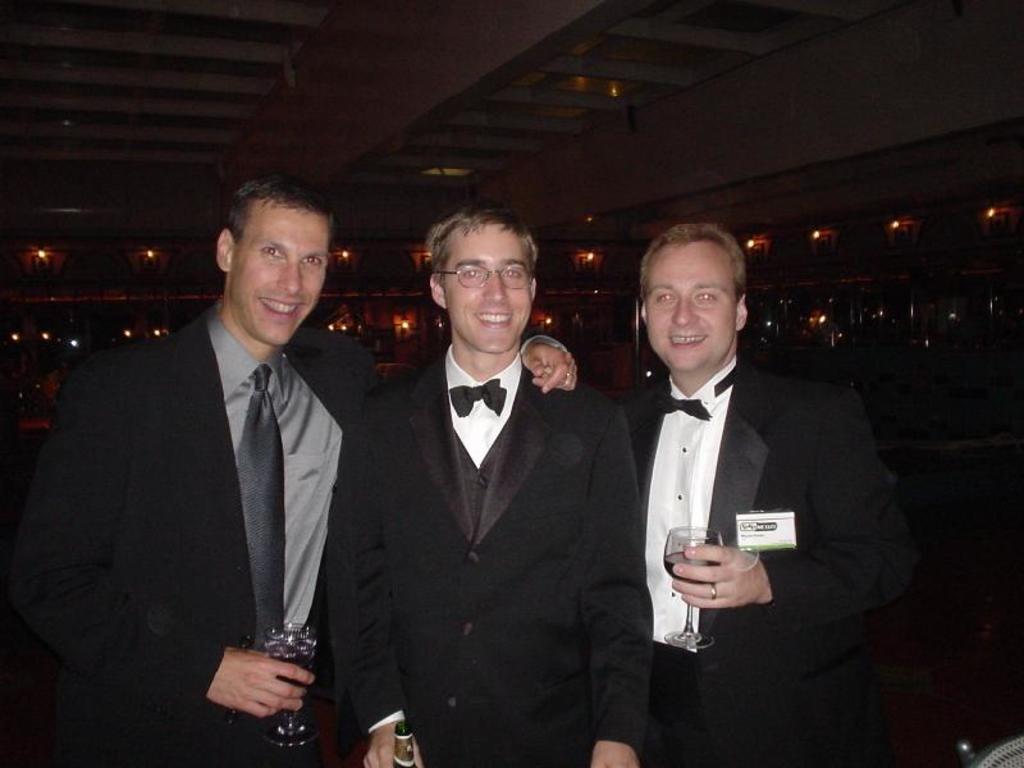Can you describe this image briefly? In this picture we can see three men are standing and smiling, a man in the middle is holding a bottle, rest of the two men are holding glasses of drinks, in the background there are some lights. 